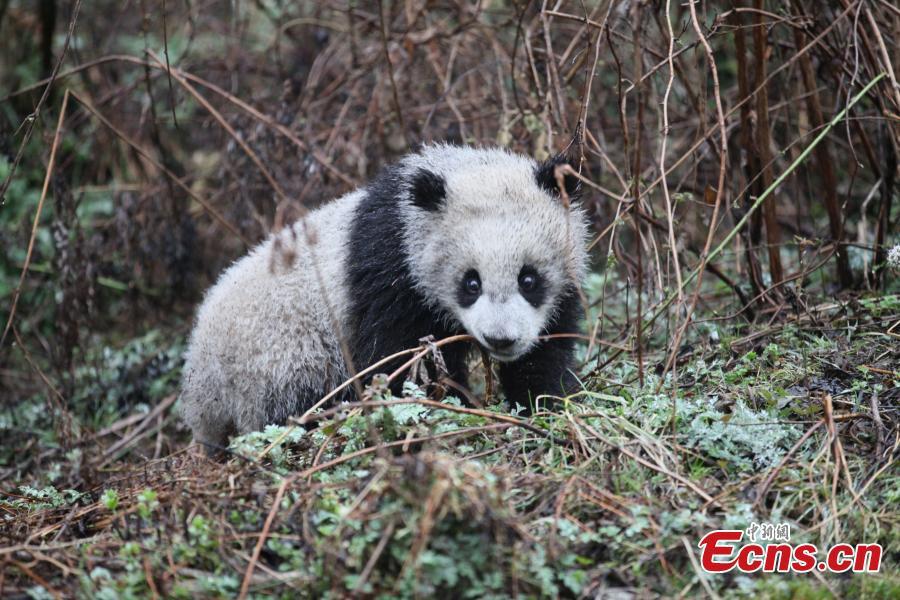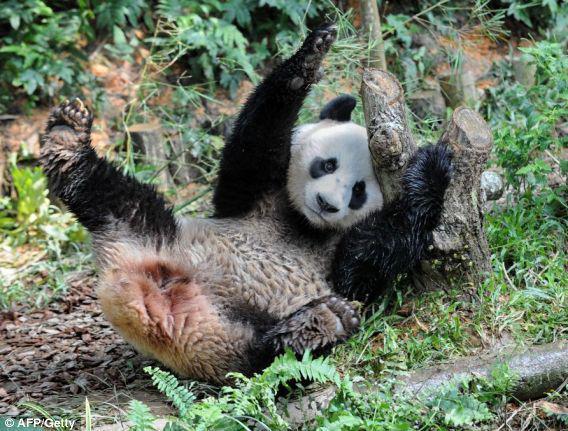The first image is the image on the left, the second image is the image on the right. For the images shown, is this caption "An image contains a single panda bear, which lies on its back with at least two paws off the ground." true? Answer yes or no. Yes. The first image is the image on the left, the second image is the image on the right. Analyze the images presented: Is the assertion "Two pandas are sitting to eat in at least one of the images." valid? Answer yes or no. No. 